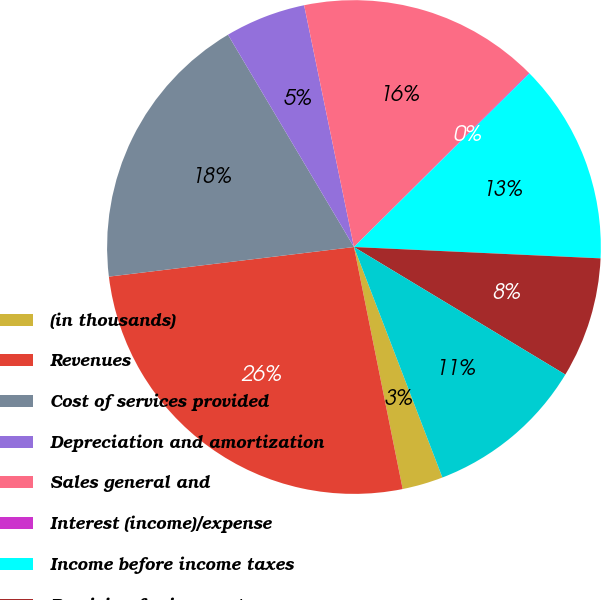<chart> <loc_0><loc_0><loc_500><loc_500><pie_chart><fcel>(in thousands)<fcel>Revenues<fcel>Cost of services provided<fcel>Depreciation and amortization<fcel>Sales general and<fcel>Interest (income)/expense<fcel>Income before income taxes<fcel>Provision for income taxes<fcel>Net income<nl><fcel>2.67%<fcel>26.25%<fcel>18.39%<fcel>5.29%<fcel>15.77%<fcel>0.05%<fcel>13.15%<fcel>7.91%<fcel>10.53%<nl></chart> 